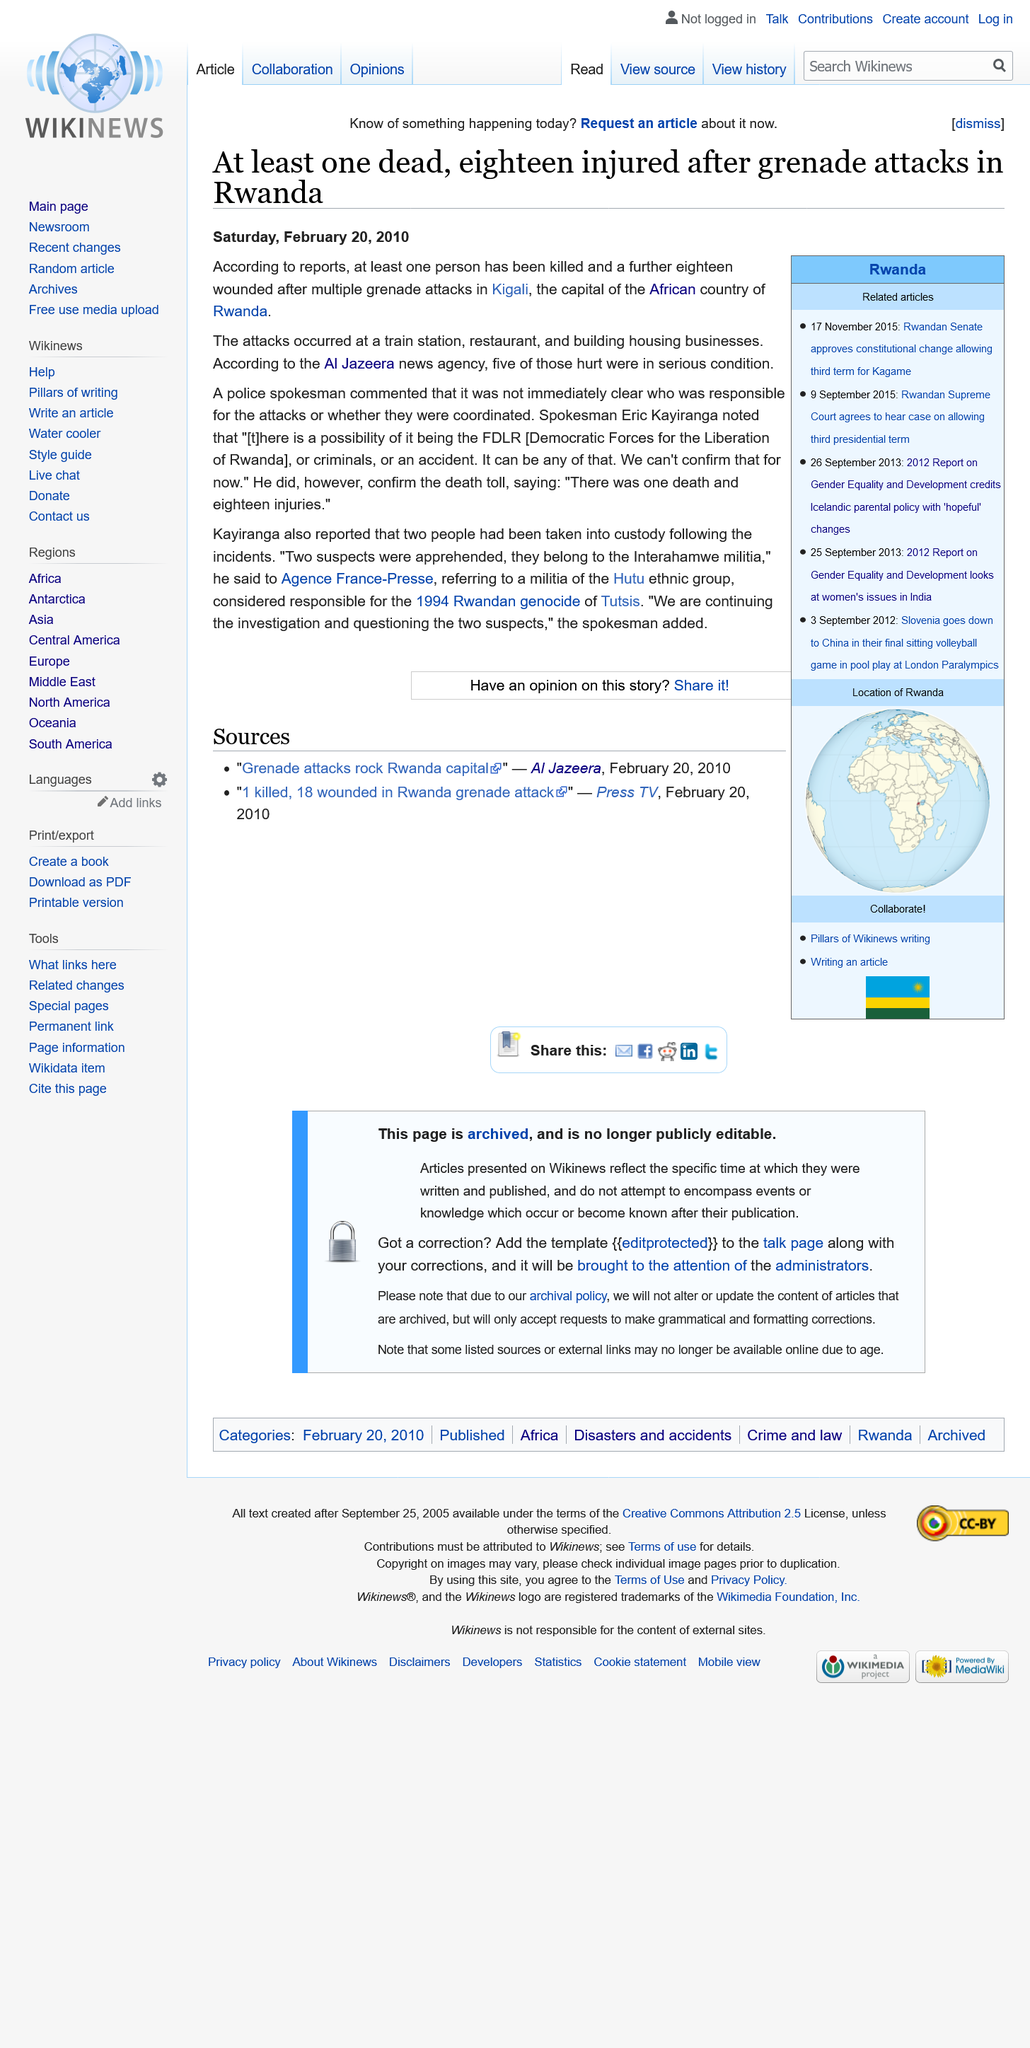Identify some key points in this picture. Eighteen people were injured in the attack. The attack resulted in the death of one person. The attacks took place in Kigali, Rwanda. 